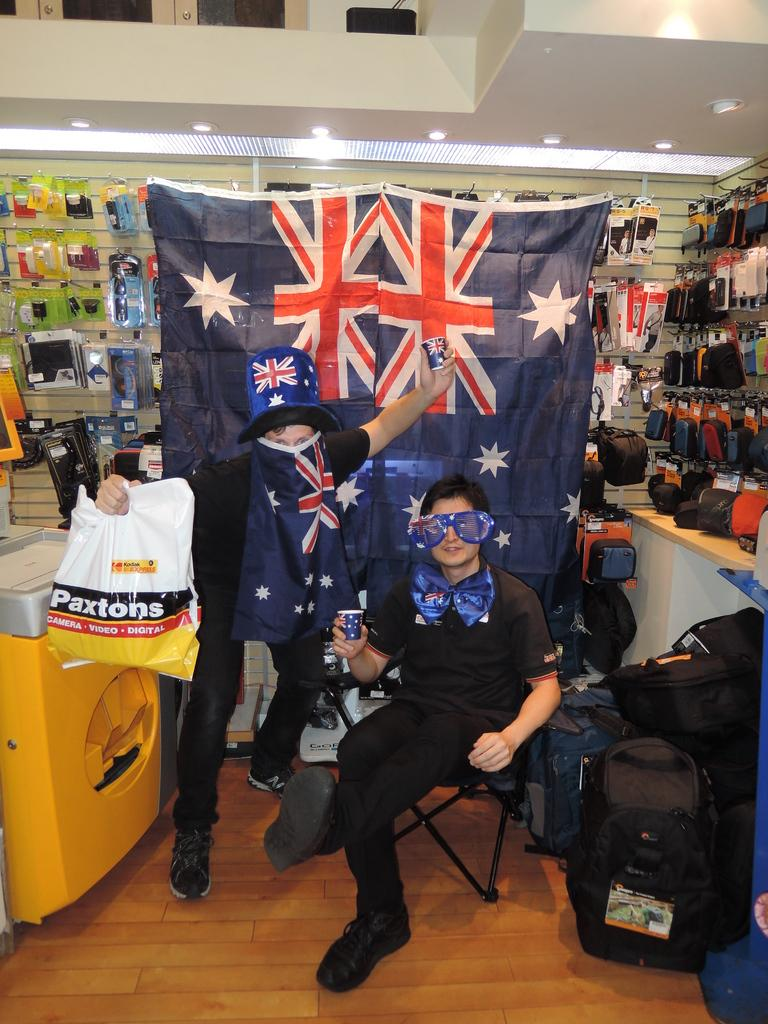<image>
Relay a brief, clear account of the picture shown. Two people wearing black are posing by a British flag and a Paxtons bag. 